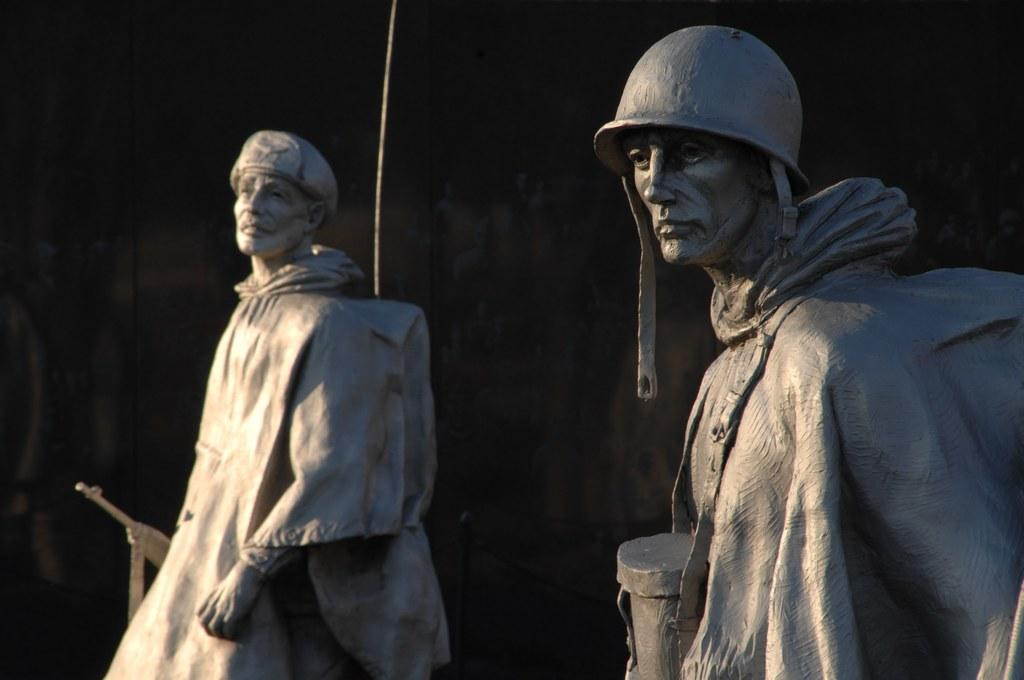How many statues are present in the image? There are two statues in the image. What can be seen behind the statues in the image? The backdrop of the image is dark. What is the reason for the statues being placed at the edge of the image? There is no indication in the image that the statues are placed at the edge, nor is there any reason provided for their placement. 